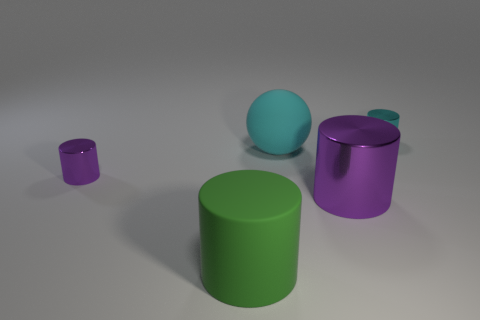Subtract 1 cylinders. How many cylinders are left? 3 Add 3 tiny brown rubber objects. How many objects exist? 8 Subtract all cylinders. How many objects are left? 1 Add 1 big spheres. How many big spheres exist? 2 Subtract 0 blue spheres. How many objects are left? 5 Subtract all yellow balls. Subtract all purple cylinders. How many objects are left? 3 Add 3 green cylinders. How many green cylinders are left? 4 